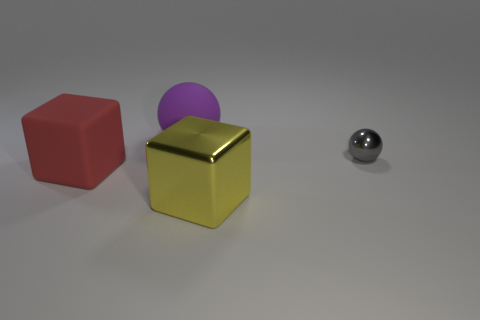What number of small balls have the same material as the large ball?
Make the answer very short. 0. There is a large thing behind the big cube that is to the left of the big yellow object; how many gray balls are behind it?
Give a very brief answer. 0. Is the shape of the big metal object the same as the purple object?
Ensure brevity in your answer.  No. Is there another gray metal object of the same shape as the tiny gray object?
Ensure brevity in your answer.  No. What is the shape of the yellow shiny object that is the same size as the matte cube?
Give a very brief answer. Cube. There is a large object that is behind the matte thing that is left of the large thing that is behind the small gray sphere; what is its material?
Provide a succinct answer. Rubber. Does the red rubber cube have the same size as the purple thing?
Your response must be concise. Yes. What is the material of the purple sphere?
Offer a very short reply. Rubber. There is a matte object behind the red rubber object; does it have the same shape as the tiny gray object?
Provide a succinct answer. Yes. What number of objects are either large objects or cubes?
Provide a short and direct response. 3. 